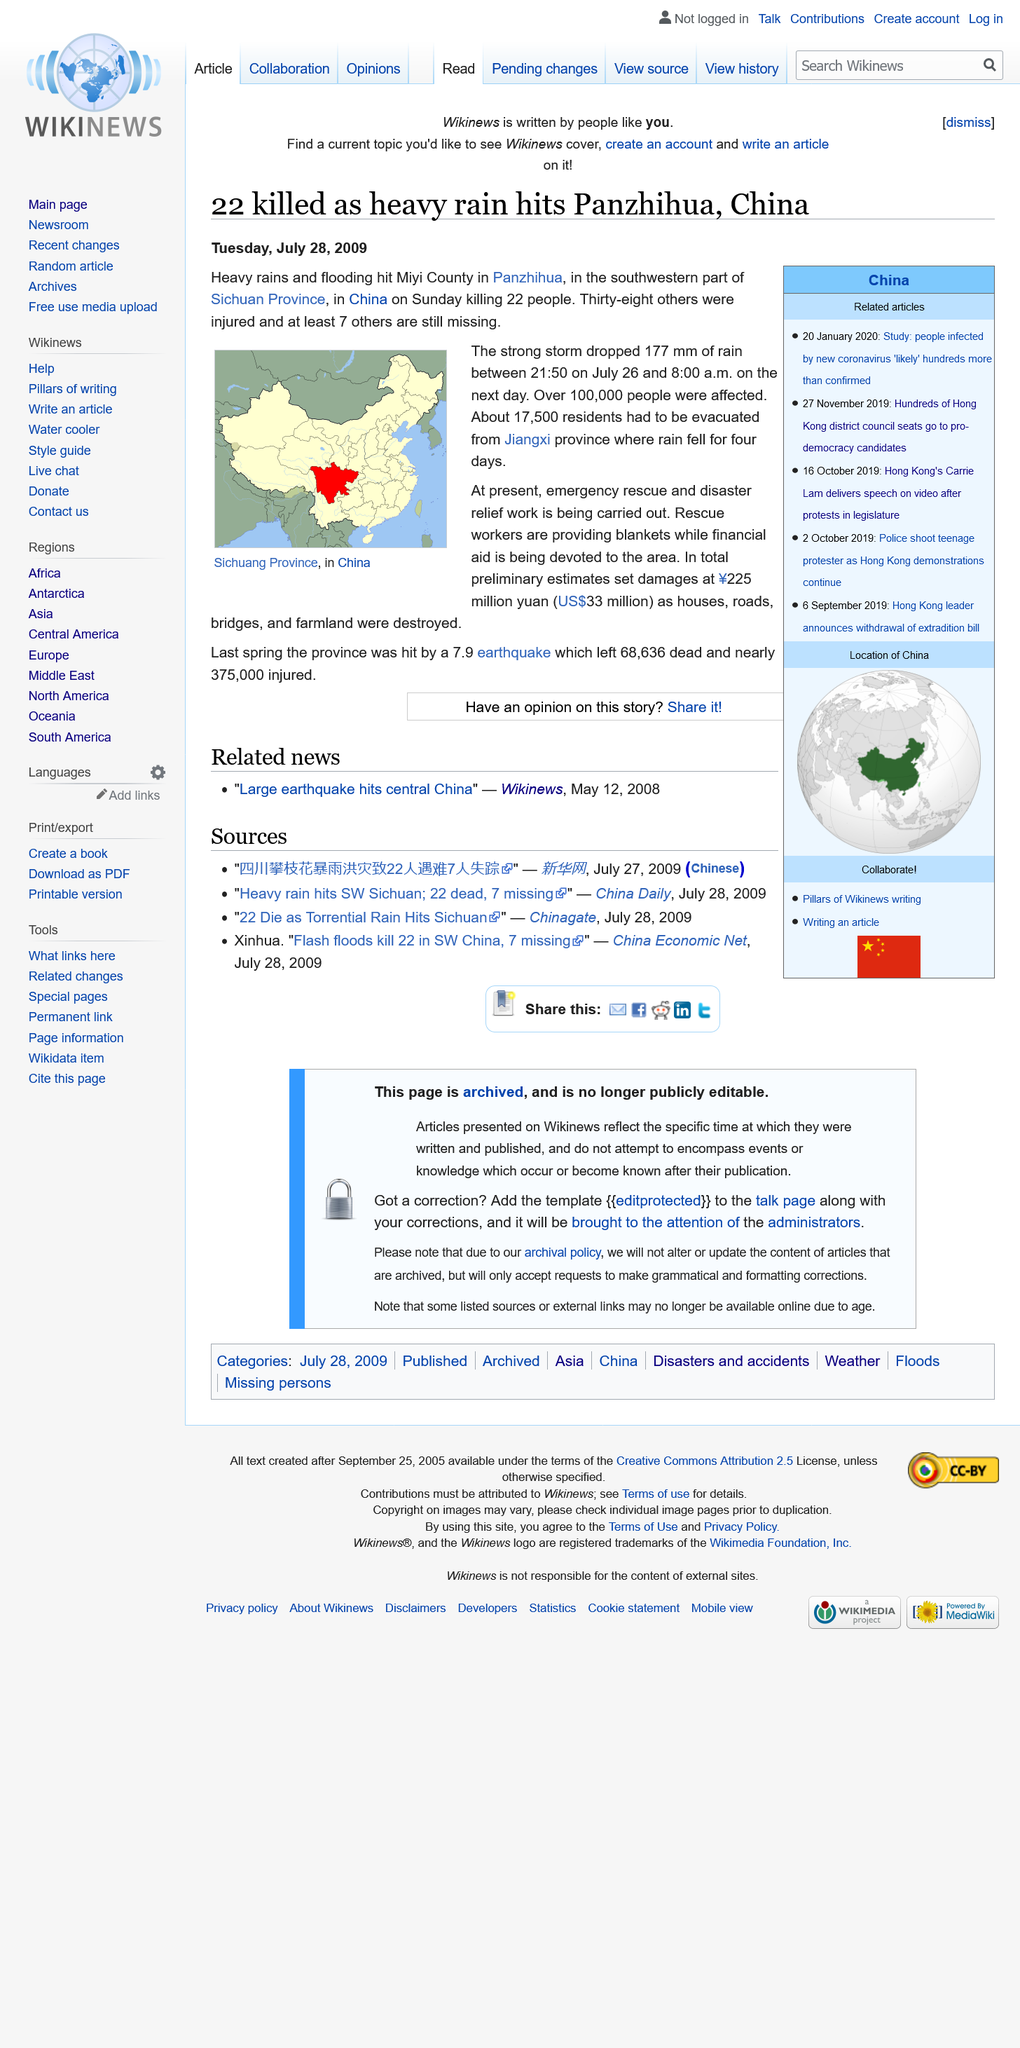Point out several critical features in this image. The estimated cost of damage caused by the flooding in Miyi County in July 2009 was 225 million yuan. Panzhihua, located in the Sichuan province of China, is in the Chinese province of Sichuan. A magnitude 7.9 earthquake hit Sichuan Province in the spring of 2008, resulting in the deaths of an estimated 68,636 people. 